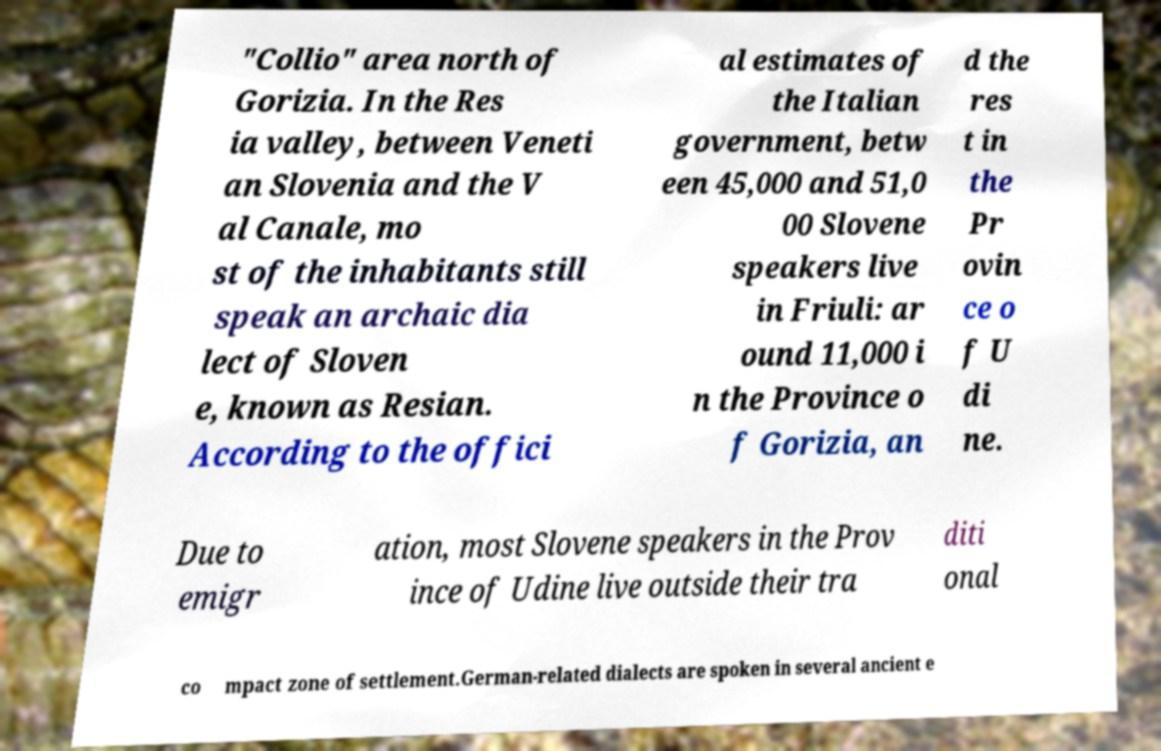Can you read and provide the text displayed in the image?This photo seems to have some interesting text. Can you extract and type it out for me? "Collio" area north of Gorizia. In the Res ia valley, between Veneti an Slovenia and the V al Canale, mo st of the inhabitants still speak an archaic dia lect of Sloven e, known as Resian. According to the offici al estimates of the Italian government, betw een 45,000 and 51,0 00 Slovene speakers live in Friuli: ar ound 11,000 i n the Province o f Gorizia, an d the res t in the Pr ovin ce o f U di ne. Due to emigr ation, most Slovene speakers in the Prov ince of Udine live outside their tra diti onal co mpact zone of settlement.German-related dialects are spoken in several ancient e 